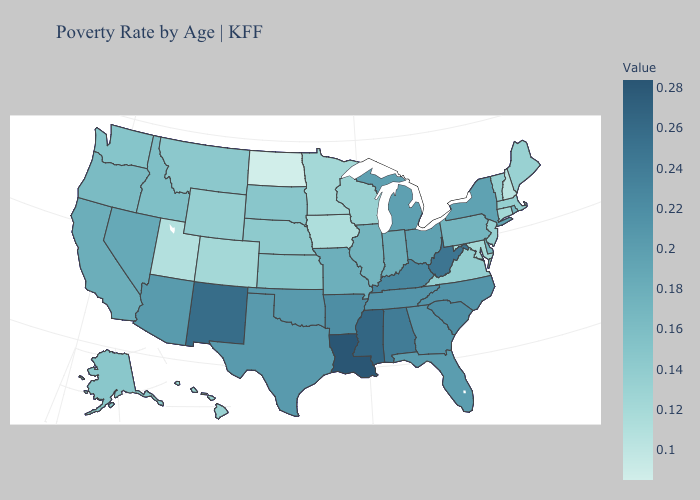Does Nebraska have a lower value than Louisiana?
Write a very short answer. Yes. Does Montana have a lower value than New York?
Keep it brief. Yes. Does Louisiana have the highest value in the USA?
Answer briefly. Yes. Which states have the lowest value in the Northeast?
Short answer required. New Hampshire. 